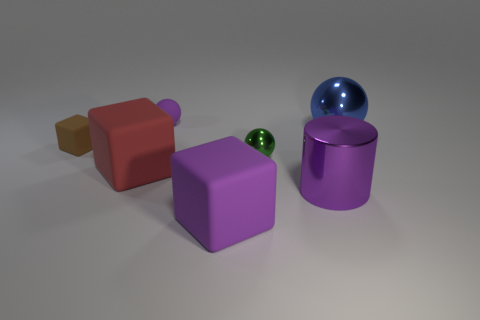There is a purple matte thing that is behind the large blue metallic thing; what number of small brown things are in front of it?
Your answer should be compact. 1. Are there fewer green spheres that are right of the tiny green ball than small cyan shiny blocks?
Your answer should be compact. No. What is the shape of the tiny object that is on the right side of the small object that is behind the rubber thing that is left of the red object?
Make the answer very short. Sphere. Do the tiny brown rubber thing and the tiny green object have the same shape?
Offer a very short reply. No. How many other objects are the same shape as the tiny brown thing?
Your answer should be compact. 2. What is the color of the cylinder that is the same size as the blue metallic object?
Give a very brief answer. Purple. Is the number of big metallic spheres behind the small purple matte thing the same as the number of tiny red matte balls?
Offer a very short reply. Yes. The rubber object that is behind the red thing and in front of the big sphere has what shape?
Provide a succinct answer. Cube. Do the red rubber cube and the purple cylinder have the same size?
Provide a succinct answer. Yes. Are there any large blue objects made of the same material as the purple sphere?
Your answer should be very brief. No. 